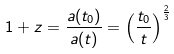Convert formula to latex. <formula><loc_0><loc_0><loc_500><loc_500>1 + z = \frac { a ( t _ { 0 } ) } { a ( t ) } = \left ( \frac { t _ { 0 } } { t } \right ) ^ { \frac { 2 } { 3 } }</formula> 